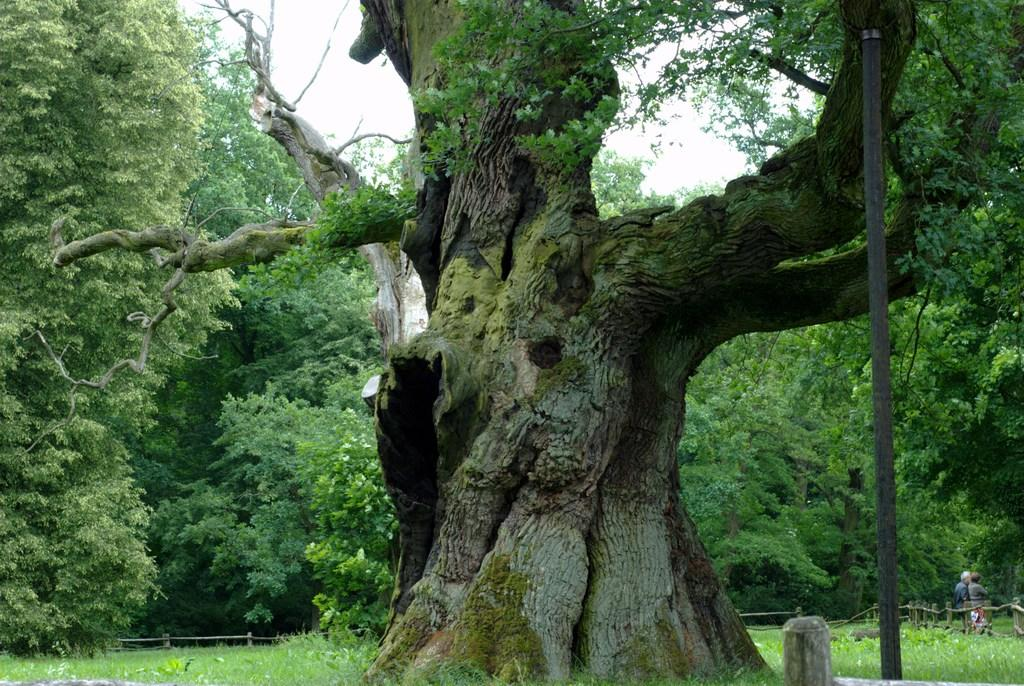What type of vegetation is present in the image? There are many trees in the image. What can be seen on the right side of the image? There is a fence on the right side of the image. How many people are in the image? There are two people in the image. What is visible in the background of the image? The sky is visible in the background of the image. What brand of toothpaste is being advertised on the fence in the image? There is no toothpaste or advertisement present on the fence in the image. What type of machine can be seen operating in the background of the image? There is no machine visible in the image; it features trees, a fence, people, and the sky. 